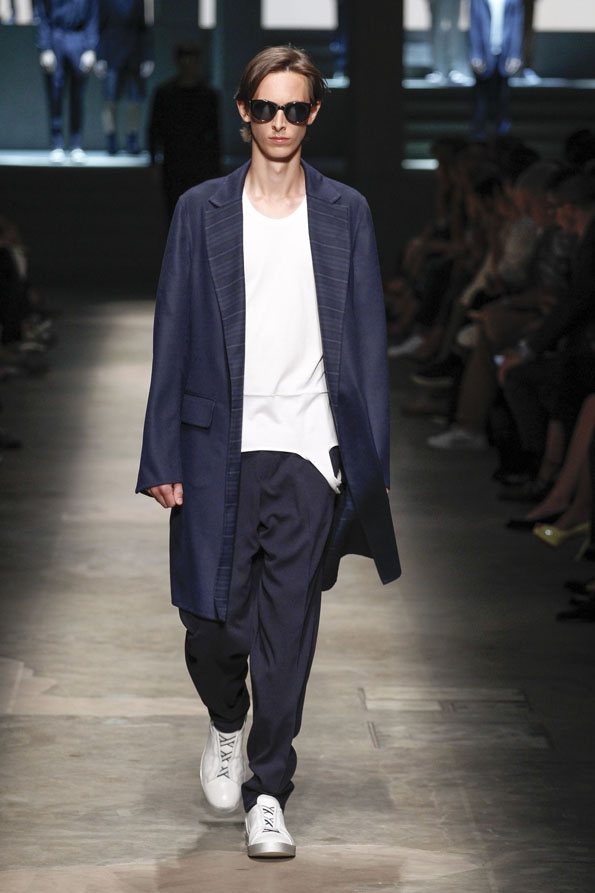A sci-fi director wants to use this outfit for a futuristic urban scene. Describe how this outfit fits that context. In a futuristic urban scene, this outfit would seamlessly fit the narrative of sophisticated modernity. The oversized navy coat, with its clean lines and tailored fit, evokes a sense of advanced technology and high fashion. The minimalistic white t-shirt and loose trousers suggest comfort and practicality, important elements in a fast-paced, futuristic cityscape. The white sneakers with their sleek design could easily be seen as high-tech footwear suited for the urban environment. The dark sunglasses add an aura of intrigue and advanced optics, possibly even reflecting augmented reality capabilities. This outfit, therefore, not only bridges contemporary fashion with futuristic elements but also underscores the evolution of style that prioritizes both aesthetics and functionality in a sci-fi setting. 
What might this outfit symbolize in a dystopian world? In a dystopian world, this outfit could symbolize a delicate balance between rebellion and conformity. The oversized navy coat might represent a form of protection or anonymity in a society where standing out could be dangerous. The minimalist white t-shirt and loose trousers suggest a utilitarian choice, reflecting a need for practicality amid chaos. White sneakers hint at adaptability and readiness to move quickly, while the dark sunglasses might serve to hide one's identity, protecting against ubiquitous surveillance. Together, these elements encapsulate a look that is both functional and subtly defiant, blending into the dystopian environment while maintaining a sense of individuality and resistance. 